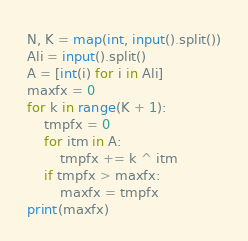Convert code to text. <code><loc_0><loc_0><loc_500><loc_500><_Python_>N, K = map(int, input().split())
Ali = input().split()
A = [int(i) for i in Ali]
maxfx = 0
for k in range(K + 1):
    tmpfx = 0
    for itm in A:
        tmpfx += k ^ itm
    if tmpfx > maxfx:
        maxfx = tmpfx
print(maxfx)</code> 